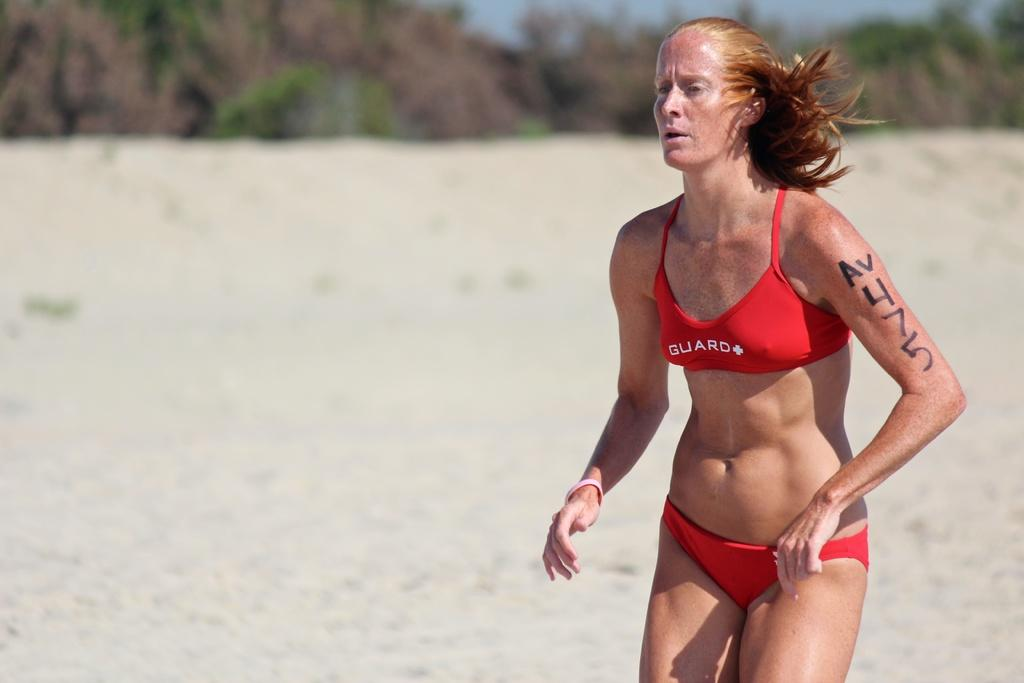<image>
Write a terse but informative summary of the picture. A woman on a beach wears an orange bikini with the word guard on the top. 